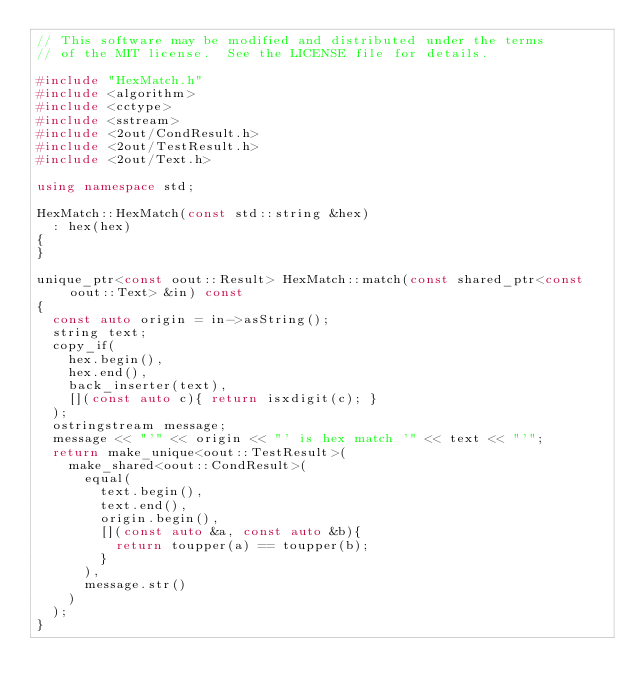<code> <loc_0><loc_0><loc_500><loc_500><_C++_>// This software may be modified and distributed under the terms
// of the MIT license.  See the LICENSE file for details.

#include "HexMatch.h"
#include <algorithm>
#include <cctype>
#include <sstream>
#include <2out/CondResult.h>
#include <2out/TestResult.h>
#include <2out/Text.h>

using namespace std;

HexMatch::HexMatch(const std::string &hex)
	: hex(hex)
{
}

unique_ptr<const oout::Result> HexMatch::match(const shared_ptr<const oout::Text> &in) const
{
	const auto origin = in->asString();
	string text;
	copy_if(
		hex.begin(),
		hex.end(),
		back_inserter(text),
		[](const auto c){ return isxdigit(c); }
	);
	ostringstream message;
	message << "'" << origin << "' is hex match '" << text << "'";
	return make_unique<oout::TestResult>(
		make_shared<oout::CondResult>(
			equal(
				text.begin(),
				text.end(),
				origin.begin(),
				[](const auto &a, const auto &b){
					return toupper(a) == toupper(b);
				}
			),
			message.str()
		)
	);
}
</code> 